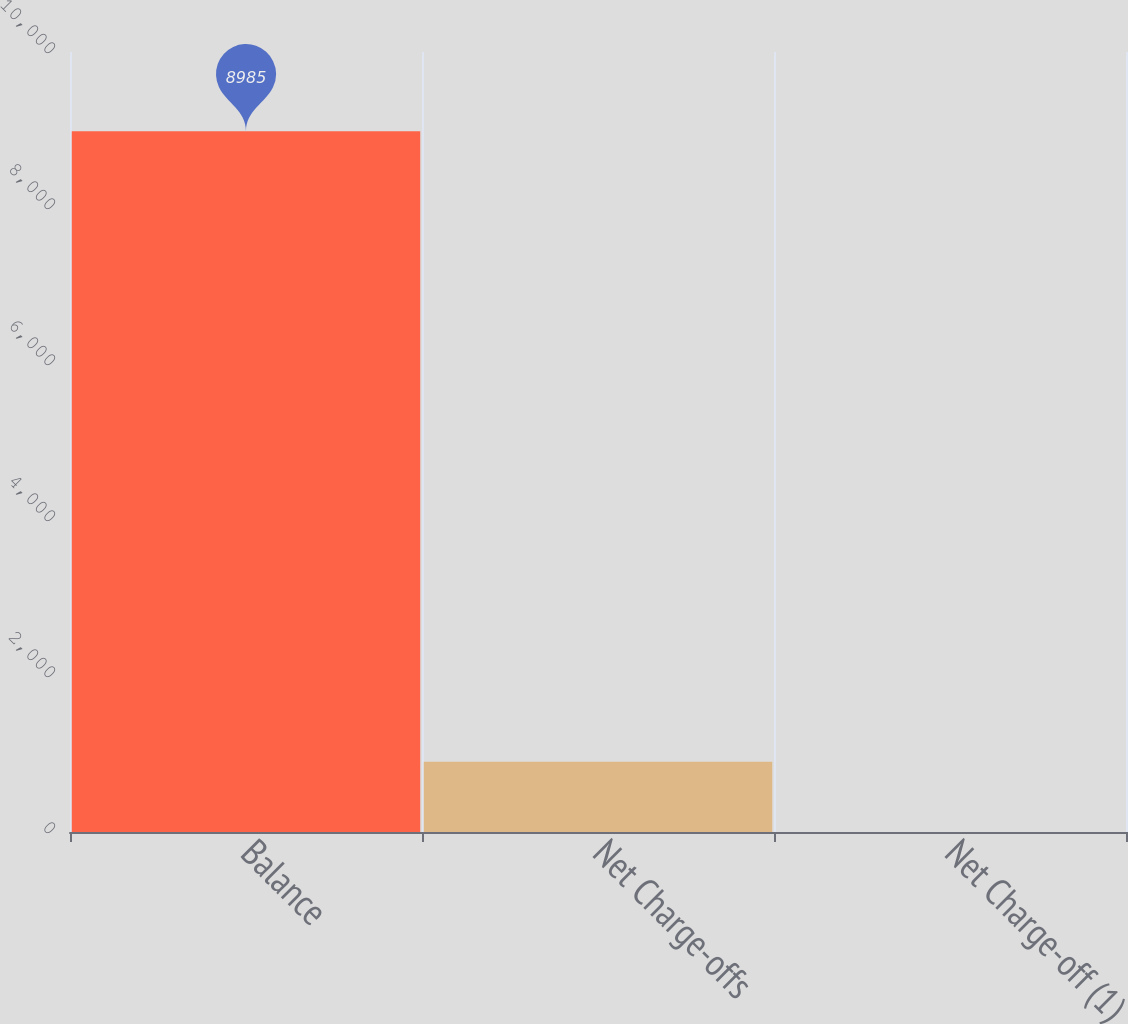Convert chart. <chart><loc_0><loc_0><loc_500><loc_500><bar_chart><fcel>Balance<fcel>Net Charge-offs<fcel>Net Charge-off (1)<nl><fcel>8985<fcel>899.67<fcel>1.3<nl></chart> 